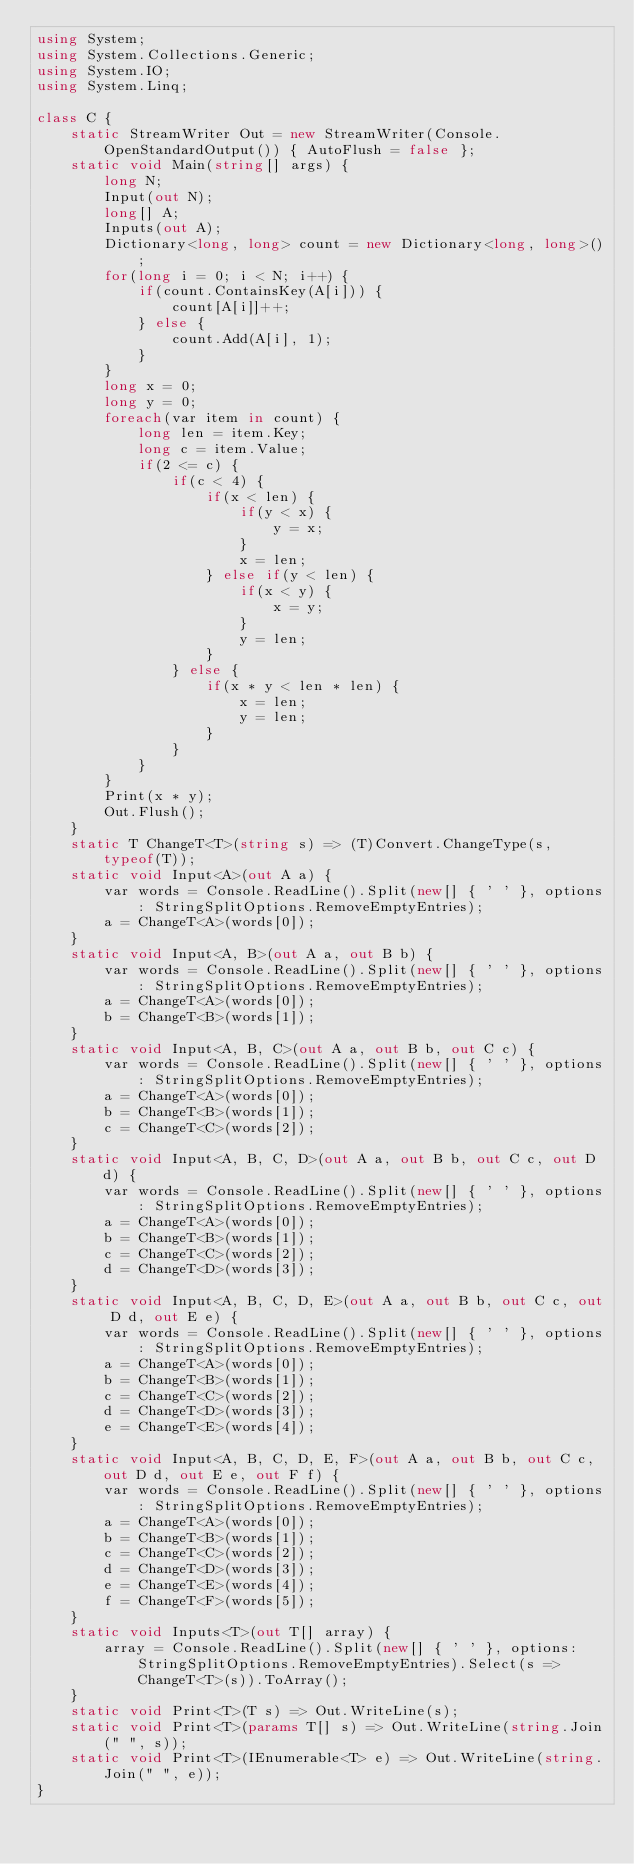Convert code to text. <code><loc_0><loc_0><loc_500><loc_500><_C#_>using System;
using System.Collections.Generic;
using System.IO;
using System.Linq;

class C {
    static StreamWriter Out = new StreamWriter(Console.OpenStandardOutput()) { AutoFlush = false };
    static void Main(string[] args) {
        long N;
        Input(out N);
        long[] A;
        Inputs(out A);
        Dictionary<long, long> count = new Dictionary<long, long>();
        for(long i = 0; i < N; i++) {
            if(count.ContainsKey(A[i])) {
                count[A[i]]++;
            } else {
                count.Add(A[i], 1);
            }
        }
        long x = 0;
        long y = 0;
        foreach(var item in count) {
            long len = item.Key;
            long c = item.Value;
            if(2 <= c) {
                if(c < 4) {
                    if(x < len) {
                        if(y < x) {
                            y = x;
                        }
                        x = len;
                    } else if(y < len) {
                        if(x < y) {
                            x = y;
                        }
                        y = len;
                    }
                } else {
                    if(x * y < len * len) {
                        x = len;
                        y = len;
                    }
                }
            }
        }
        Print(x * y);
        Out.Flush();
    }
    static T ChangeT<T>(string s) => (T)Convert.ChangeType(s, typeof(T));
    static void Input<A>(out A a) {
        var words = Console.ReadLine().Split(new[] { ' ' }, options: StringSplitOptions.RemoveEmptyEntries);
        a = ChangeT<A>(words[0]);
    }
    static void Input<A, B>(out A a, out B b) {
        var words = Console.ReadLine().Split(new[] { ' ' }, options: StringSplitOptions.RemoveEmptyEntries);
        a = ChangeT<A>(words[0]);
        b = ChangeT<B>(words[1]);
    }
    static void Input<A, B, C>(out A a, out B b, out C c) {
        var words = Console.ReadLine().Split(new[] { ' ' }, options: StringSplitOptions.RemoveEmptyEntries);
        a = ChangeT<A>(words[0]);
        b = ChangeT<B>(words[1]);
        c = ChangeT<C>(words[2]);
    }
    static void Input<A, B, C, D>(out A a, out B b, out C c, out D d) {
        var words = Console.ReadLine().Split(new[] { ' ' }, options: StringSplitOptions.RemoveEmptyEntries);
        a = ChangeT<A>(words[0]);
        b = ChangeT<B>(words[1]);
        c = ChangeT<C>(words[2]);
        d = ChangeT<D>(words[3]);
    }
    static void Input<A, B, C, D, E>(out A a, out B b, out C c, out D d, out E e) {
        var words = Console.ReadLine().Split(new[] { ' ' }, options: StringSplitOptions.RemoveEmptyEntries);
        a = ChangeT<A>(words[0]);
        b = ChangeT<B>(words[1]);
        c = ChangeT<C>(words[2]);
        d = ChangeT<D>(words[3]);
        e = ChangeT<E>(words[4]);
    }
    static void Input<A, B, C, D, E, F>(out A a, out B b, out C c, out D d, out E e, out F f) {
        var words = Console.ReadLine().Split(new[] { ' ' }, options: StringSplitOptions.RemoveEmptyEntries);
        a = ChangeT<A>(words[0]);
        b = ChangeT<B>(words[1]);
        c = ChangeT<C>(words[2]);
        d = ChangeT<D>(words[3]);
        e = ChangeT<E>(words[4]);
        f = ChangeT<F>(words[5]);
    }
    static void Inputs<T>(out T[] array) {
        array = Console.ReadLine().Split(new[] { ' ' }, options: StringSplitOptions.RemoveEmptyEntries).Select(s => ChangeT<T>(s)).ToArray();
    }
    static void Print<T>(T s) => Out.WriteLine(s);
    static void Print<T>(params T[] s) => Out.WriteLine(string.Join(" ", s));
    static void Print<T>(IEnumerable<T> e) => Out.WriteLine(string.Join(" ", e));
}</code> 